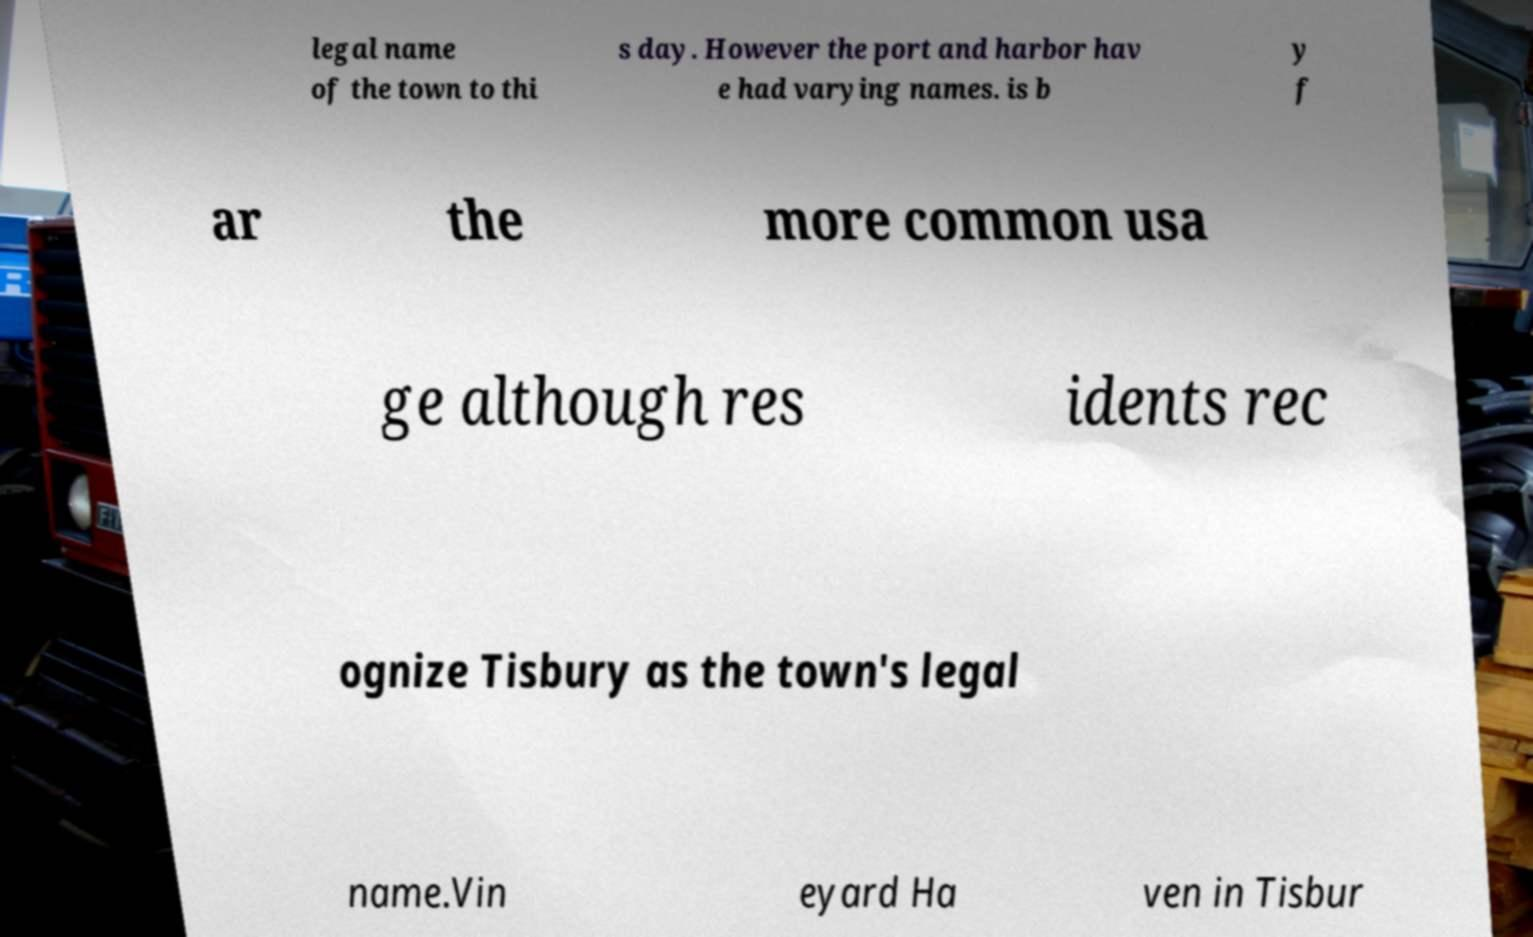There's text embedded in this image that I need extracted. Can you transcribe it verbatim? legal name of the town to thi s day. However the port and harbor hav e had varying names. is b y f ar the more common usa ge although res idents rec ognize Tisbury as the town's legal name.Vin eyard Ha ven in Tisbur 